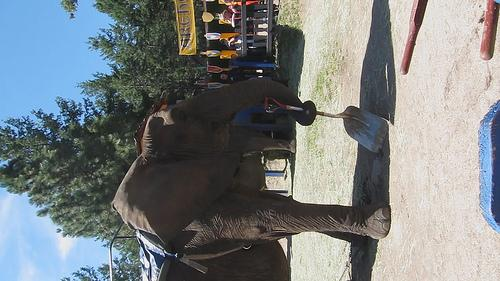Enumerate two objects in the image that are blue in color, and describe their shape or function. Two blue objects are a wide object on the ground and a saddle or seat on the elephant. Elaborate on the presence of shadows in the image, and which object they pertain to. There is a shadow on the ground which belongs to the large elephant standing by the grey fencing rails. Describe an important detail about the elephant's appearance, and what it is holding. The grey elephant has wrinkly skin on its leg and is holding a dirty shovel with a brownish-red wooden handle. Provide a brief description of the primary object in the image and its action. An elephant is holding a shovel, most likely engaged in some sort of digging. What type of environment is the image set in, and how many total trees can you spot? The setting is an elephant enclosure with at least five trees in the background. Describe any special characteristic of the area, and any interesting details observed in the enclosure. The enclosure has sand and dirt, grey fencing rails, a patch of green grass, and a few shops on the sides of the road. List two objects of interest that are above any people in the image. A yellow banner and a yellow and blue arctic sign are located above the people. Mention something notable about the sky and the time of day in the image. The sky is blue with wispy white clouds, and the image was taken during daytime. Identify the tallest tree in the image and any significant characteristics. The tallest tree is behind the elephant, and it's a tall green tree with leaves. What type of object can be seen on the elephant and what color is it? A blue seat, possibly a saddle or blanket, is worn by the elephant. Identify the color of the seat on the elephant. Blue Describe the emotions you would expect the people in this setting to feel based on the given information. Excited or curious, as they are observing the elephant holding a shovel in its enclosure Choose the correct description for the object on the elephant: a) Yellow banner, b) Harness, c) Blue seat, d) Grey fencing rails c) Blue seat What is the elephant holding in the image? A shovel Describe the weather in the image, including the state of the sky and the presence of clouds. Bright blue sky with wispy white clouds Can you see the orange banner above the people? There is a banner above the people, but it is described as "a yellow banner" in the captions, not orange. Determine any object in the image that represents a mode of transportation for people. Blue seat on the elephant Is the elephant holding a blue shovel? The elephant is holding a shovel, but the handle is described as "brownish red wooden handles" and "red handle" in the captions, not blue. Select appropriate adjectives to describe the elephant's appearance. Grey, large, wrinkly Compose a short story using the given images as inspiration. Once upon a time, in an elephant enclosure, a charming grey elephant with a saddle was holding a shovel, ready to dig. As the sun shone brightly over the scene, casting the elephant's shadow on the ground, the green trees swayed gently in the background. Nearby, excited spectators gathered to watch this fascinating event from behind the grey fencing rails. Based on the given information, describe the conditions and appearance of the elephant enclosure. The elephant enclosure has sand and dirt, grey fencing rails, and is surrounded by tall green trees. Identify any objects in the image that indicate a boundary for the elephant. Grey fencing rails and a saddle or blanket worn by the elephant Which objects show the presence of humans in the image? Yellow banner, grey fencing rails, saddle or blanket, and harness What activity does the elephant seem to be doing? The elephant is holding a digger or shovel, potentially for digging. Does the elephant have pink wrinkly skin on its leg? The elephant's skin is described as "wrinkly grey skin on elephants leg" and "grey color elephant" in the captions, not pink. Is there a red seat on the elephant? There is a seat on the elephant, but it is described as "a saddle or blanket worn by the elephant," "blue seat on elephant," and "harness on elephant" in the captions, not red. Characterize the atmosphere in the image by analyzing the clouds and sky. Clear, sunny day with a few wispy clouds Observe the given information and deduce the color of the surrounding trees. Green How would you describe the trees in the image? Tall, green, growing in the background From the images, make an inference regarding the environment or setting. The setting is an elephant enclosure with trees, grass, and shops in the background. Is the sky green in the picture? The sky is described as "blue sky with wispy clouds," "sky is blue color," and "white clouds in the blue skies"  in the captions, not green. Determine whether the captured image was taken during daytime or nighttime. Daytime What does the shadow in the image suggest about the time of day? It suggests that it's daytime with sunlight. Pinpoint the location of a specific object: the large green tree. The large green tree is behind the elephant. Are the trees in the background purple? The trees are described as "tall green tree," "trees are green," "leaves are green," and "section of green tree" in the captions, not purple. 